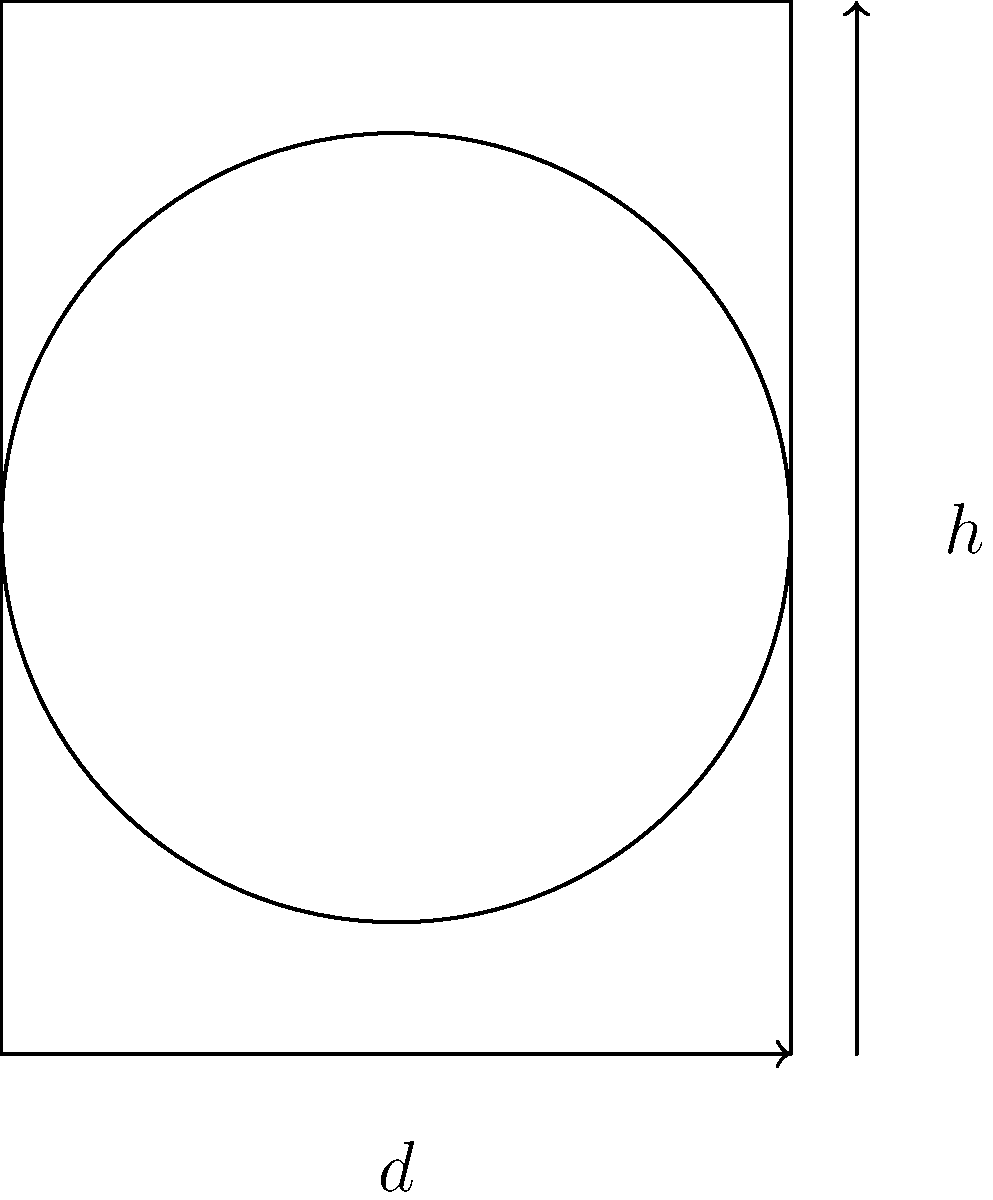You have a cylindrical fish barrel with a diameter of 60 cm. What is the circumference of the barrel's circular base? To find the circumference of the circular base of the fish barrel, we need to use the formula for the circumference of a circle:

$$C = \pi d$$

Where:
$C$ is the circumference
$\pi$ is pi (approximately 3.14159)
$d$ is the diameter

Given:
Diameter ($d$) = 60 cm

Step 1: Substitute the values into the formula
$$C = \pi \times 60\text{ cm}$$

Step 2: Calculate
$$C \approx 3.14159 \times 60\text{ cm}$$
$$C \approx 188.50\text{ cm}$$

Therefore, the circumference of the barrel's circular base is approximately 188.50 cm.
Answer: $188.50\text{ cm}$ 